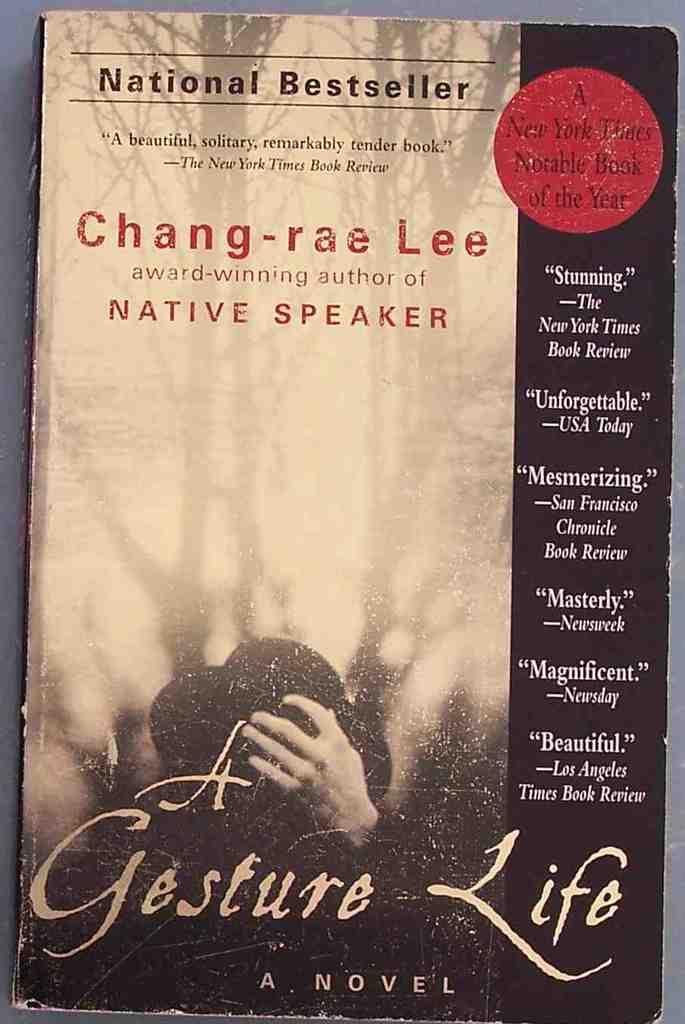What is the name of the novel?
Your response must be concise. A gesture life. What is the author's name?
Your answer should be compact. Chang-rae lee. 